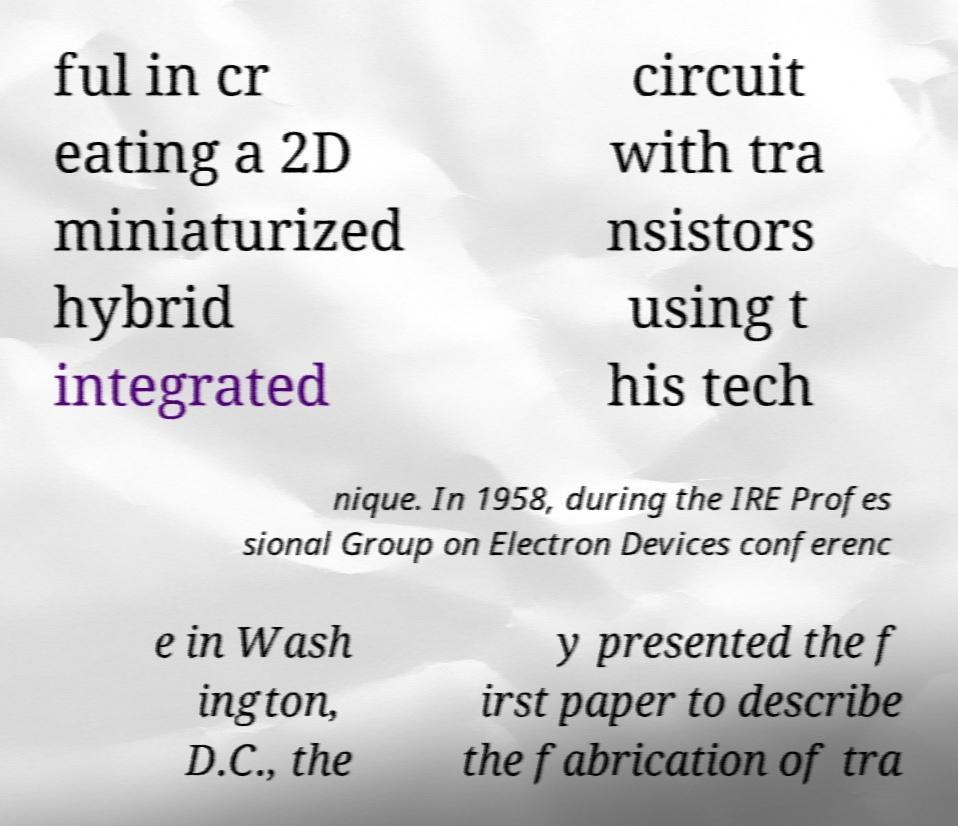Please read and relay the text visible in this image. What does it say? ful in cr eating a 2D miniaturized hybrid integrated circuit with tra nsistors using t his tech nique. In 1958, during the IRE Profes sional Group on Electron Devices conferenc e in Wash ington, D.C., the y presented the f irst paper to describe the fabrication of tra 